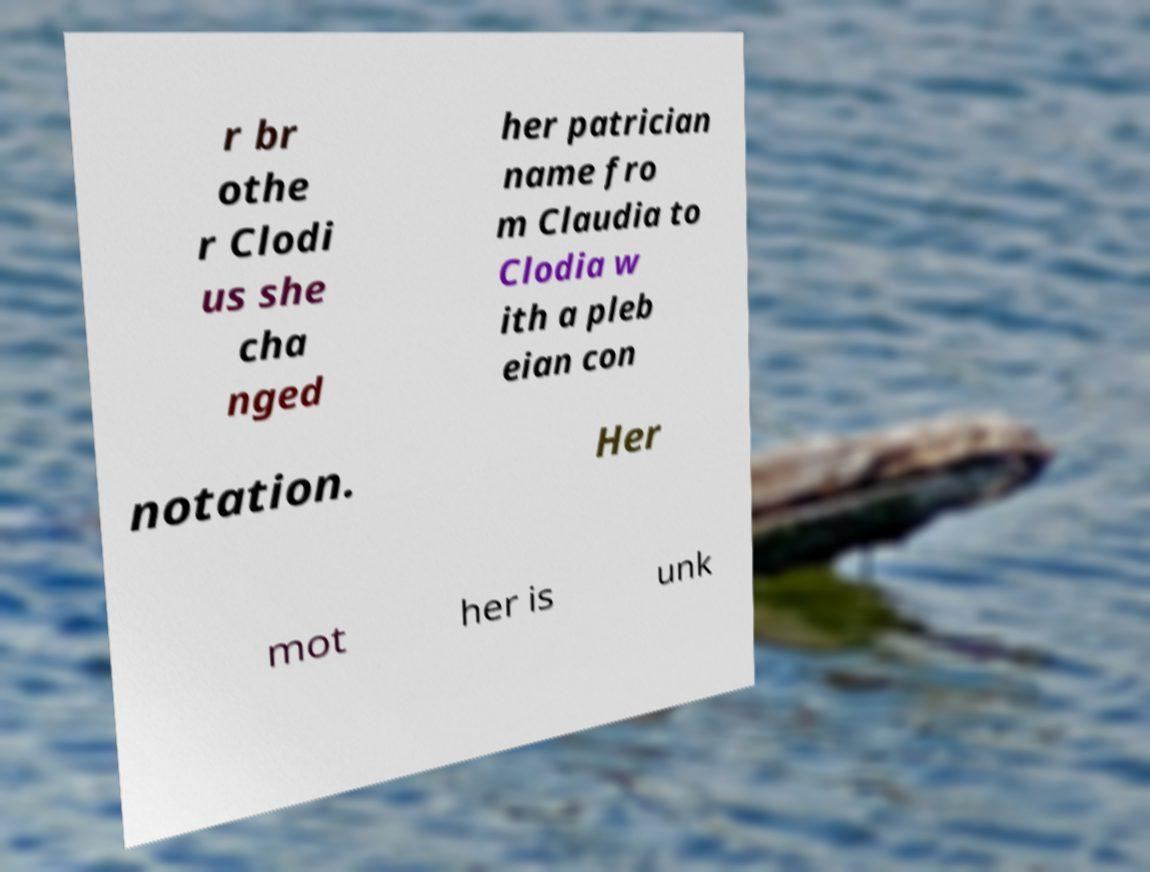There's text embedded in this image that I need extracted. Can you transcribe it verbatim? r br othe r Clodi us she cha nged her patrician name fro m Claudia to Clodia w ith a pleb eian con notation. Her mot her is unk 